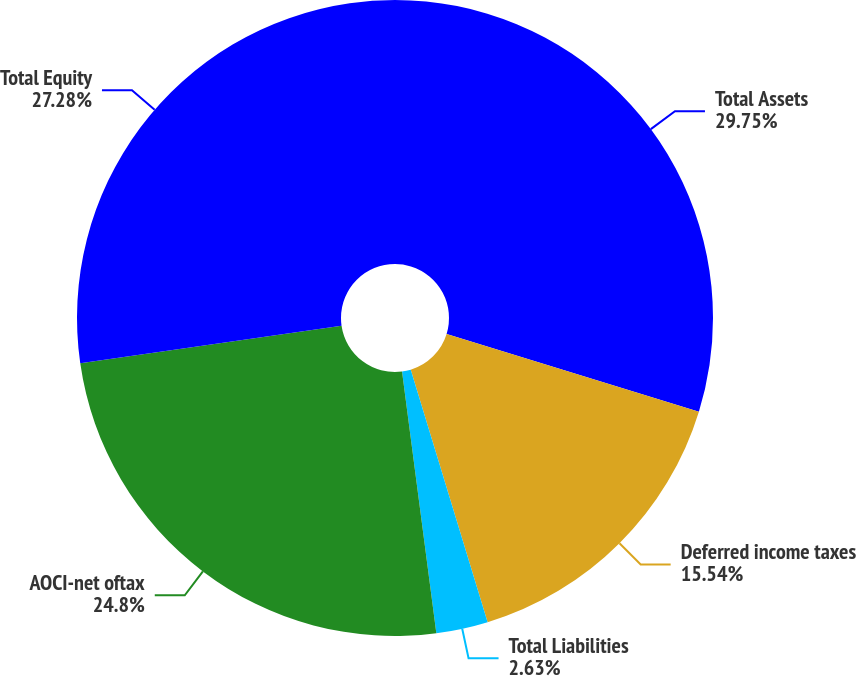<chart> <loc_0><loc_0><loc_500><loc_500><pie_chart><fcel>Total Assets<fcel>Deferred income taxes<fcel>Total Liabilities<fcel>AOCI-net oftax<fcel>Total Equity<nl><fcel>29.76%<fcel>15.54%<fcel>2.63%<fcel>24.8%<fcel>27.28%<nl></chart> 